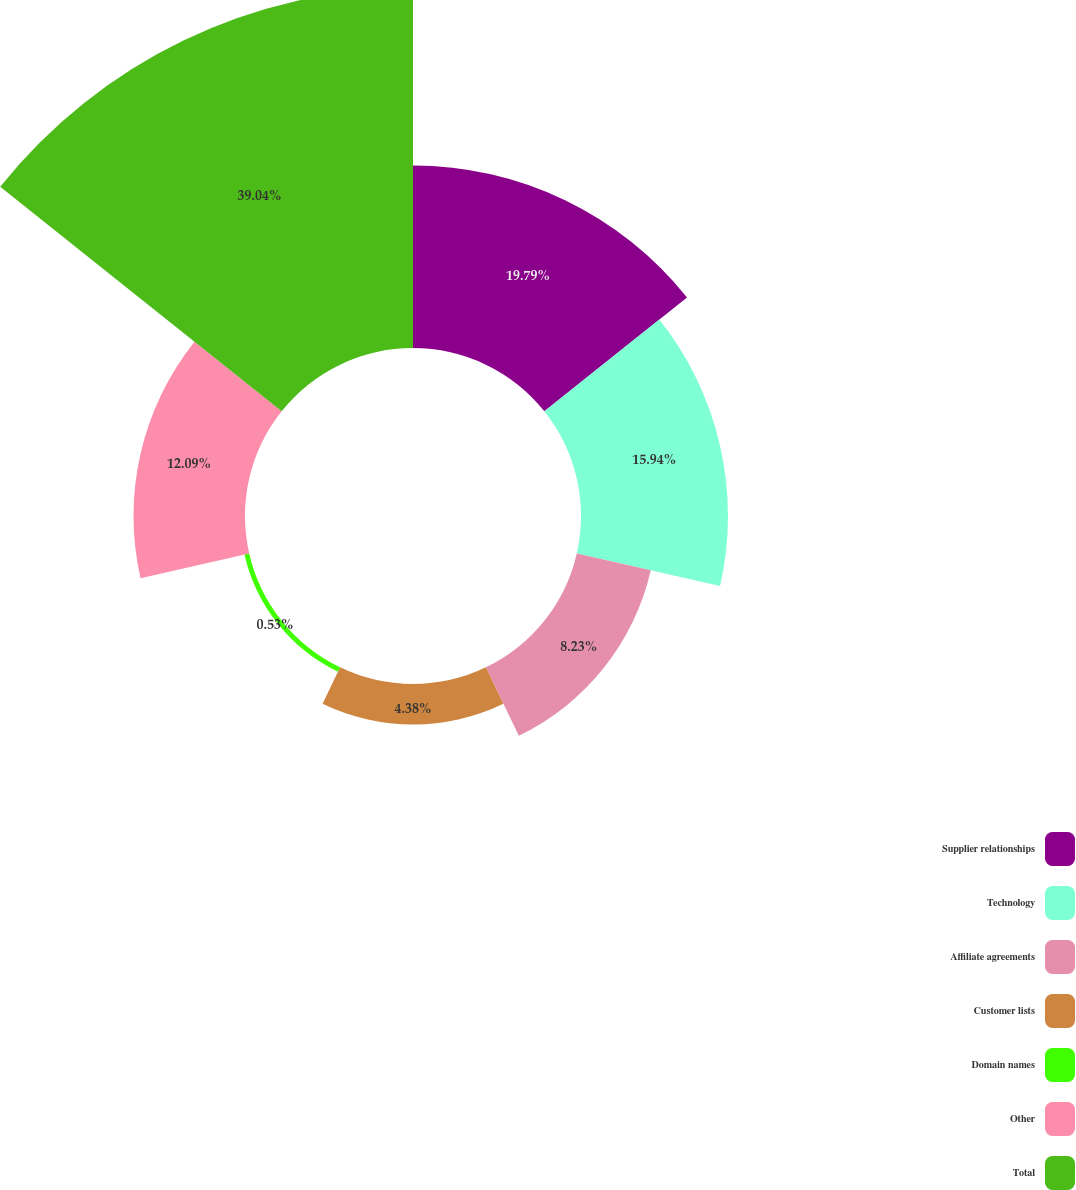Convert chart. <chart><loc_0><loc_0><loc_500><loc_500><pie_chart><fcel>Supplier relationships<fcel>Technology<fcel>Affiliate agreements<fcel>Customer lists<fcel>Domain names<fcel>Other<fcel>Total<nl><fcel>19.79%<fcel>15.94%<fcel>8.23%<fcel>4.38%<fcel>0.53%<fcel>12.09%<fcel>39.04%<nl></chart> 